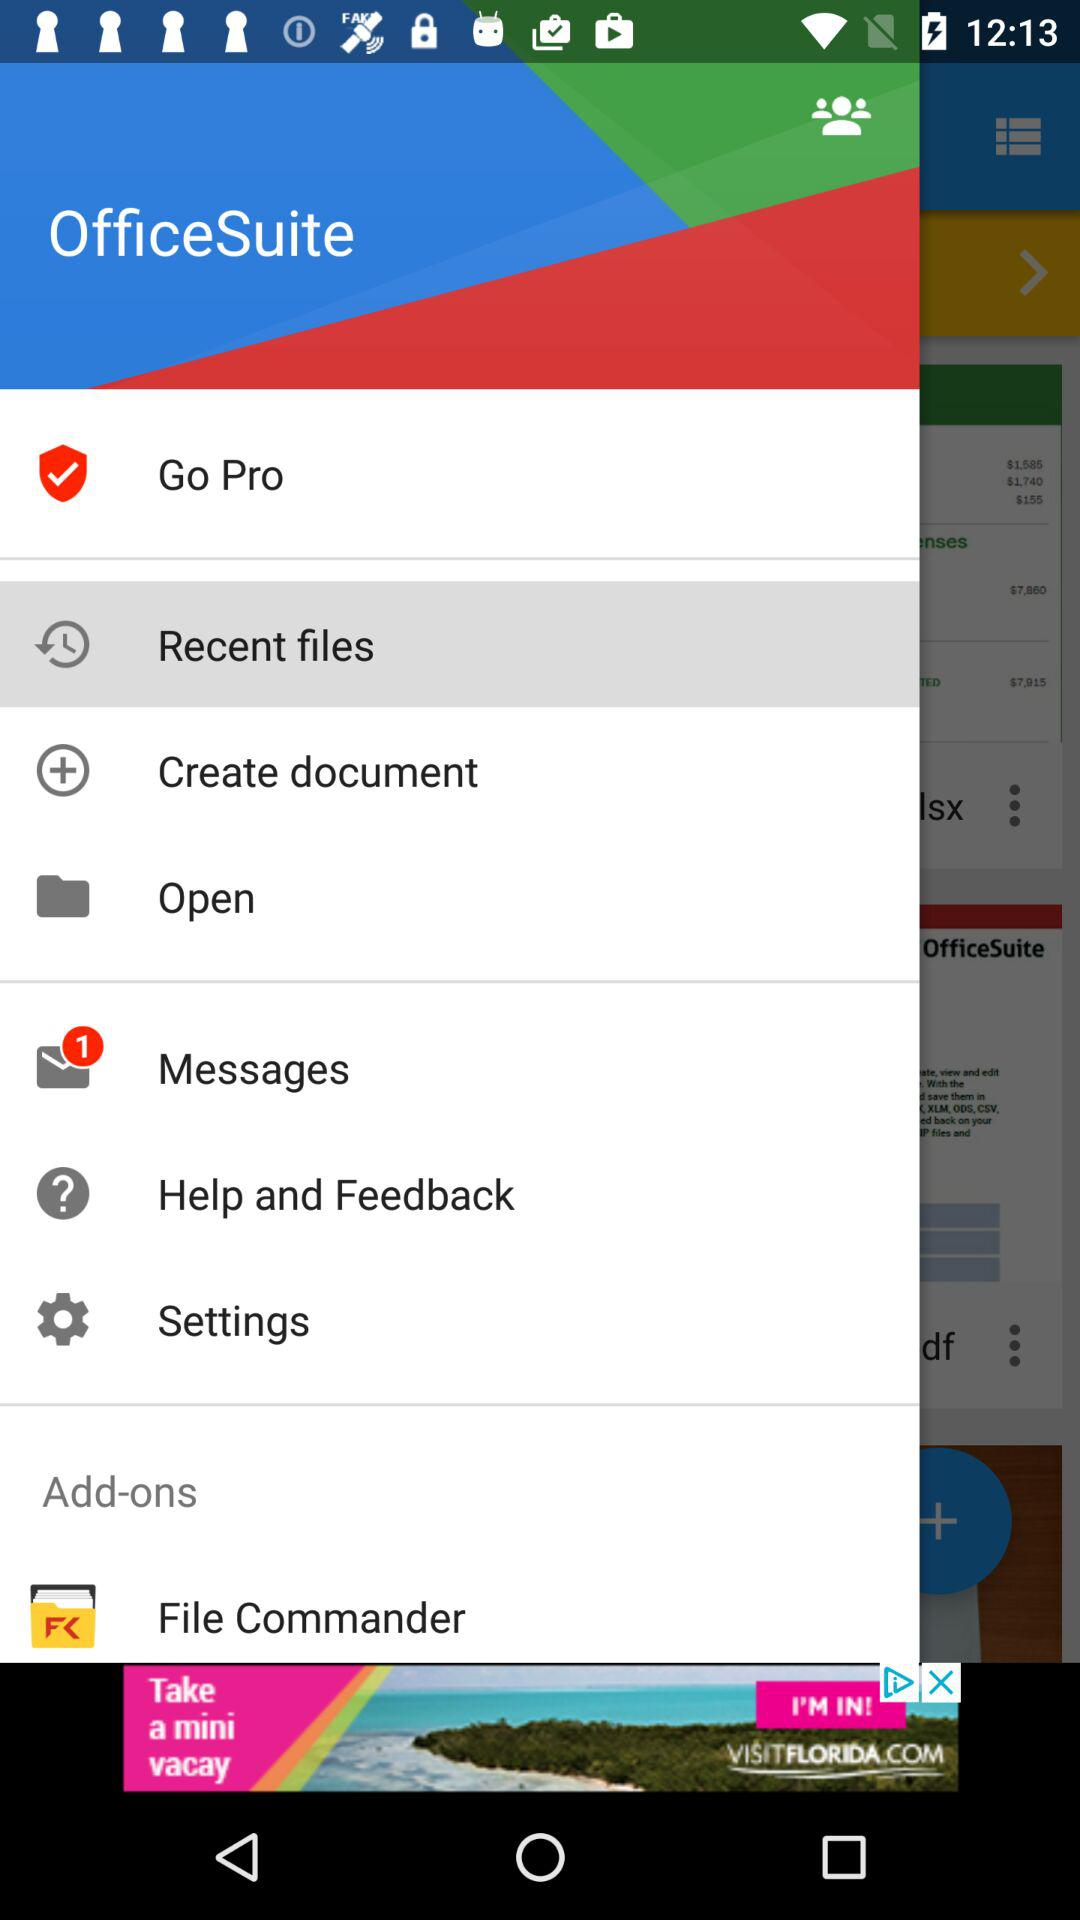What are the recent files?
When the provided information is insufficient, respond with <no answer>. <no answer> 